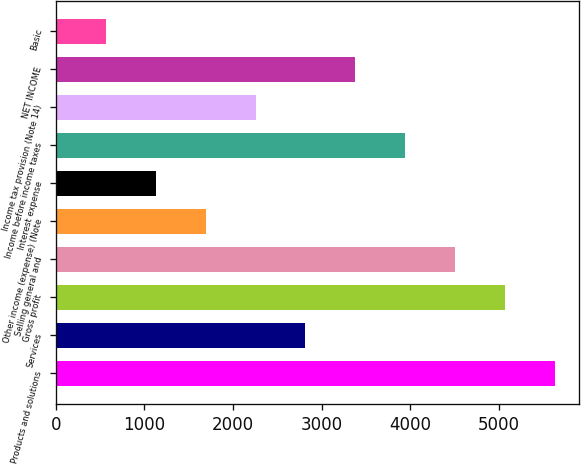<chart> <loc_0><loc_0><loc_500><loc_500><bar_chart><fcel>Products and solutions<fcel>Services<fcel>Gross profit<fcel>Selling general and<fcel>Other income (expense) (Note<fcel>Interest expense<fcel>Income before income taxes<fcel>Income tax provision (Note 14)<fcel>NET INCOME<fcel>Basic<nl><fcel>5628.9<fcel>2817.64<fcel>5066.65<fcel>4504.39<fcel>1693.12<fcel>1130.87<fcel>3942.14<fcel>2255.38<fcel>3379.89<fcel>568.61<nl></chart> 